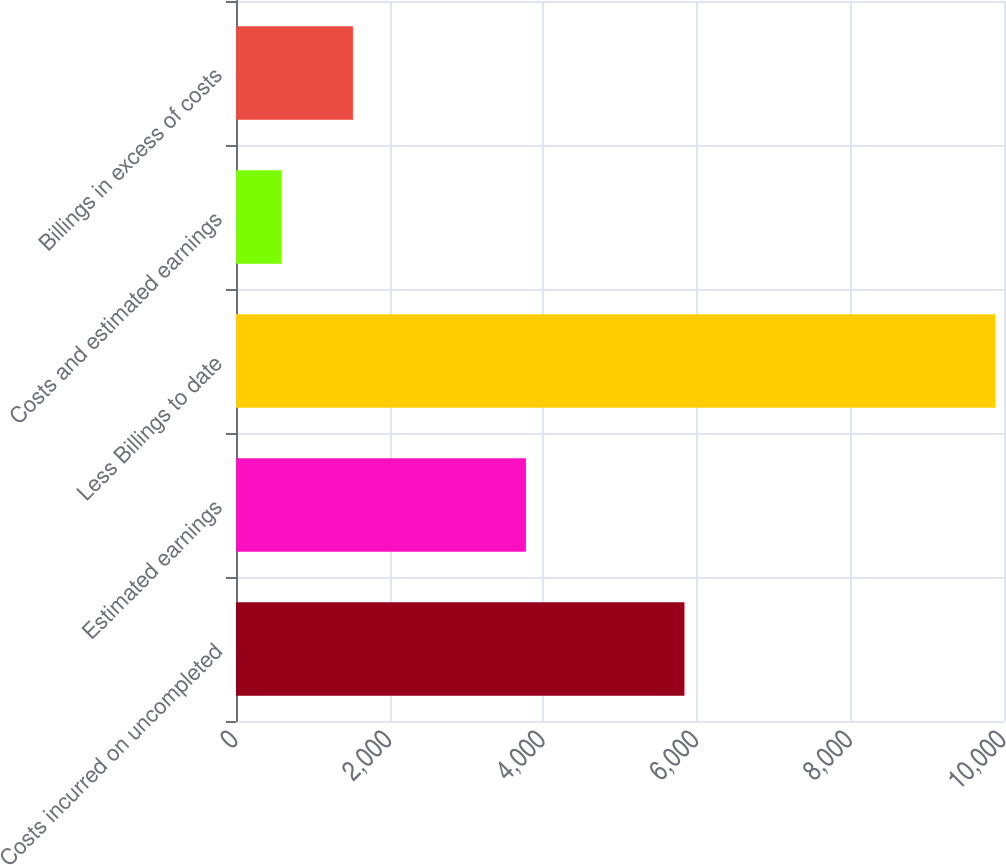Convert chart to OTSL. <chart><loc_0><loc_0><loc_500><loc_500><bar_chart><fcel>Costs incurred on uncompleted<fcel>Estimated earnings<fcel>Less Billings to date<fcel>Costs and estimated earnings<fcel>Billings in excess of costs<nl><fcel>5839<fcel>3775<fcel>9886<fcel>593<fcel>1522.3<nl></chart> 